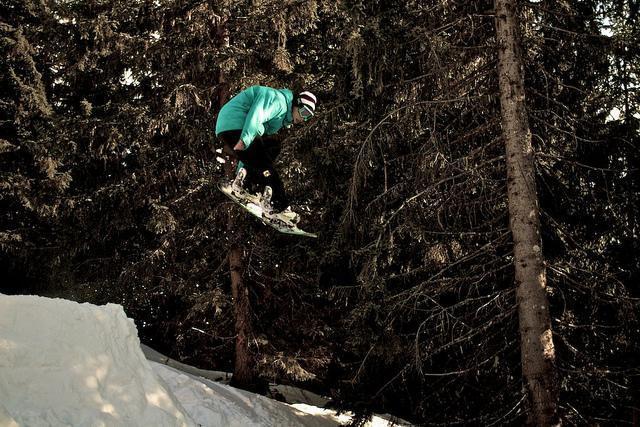How many sandwiches with orange paste are in the picture?
Give a very brief answer. 0. 